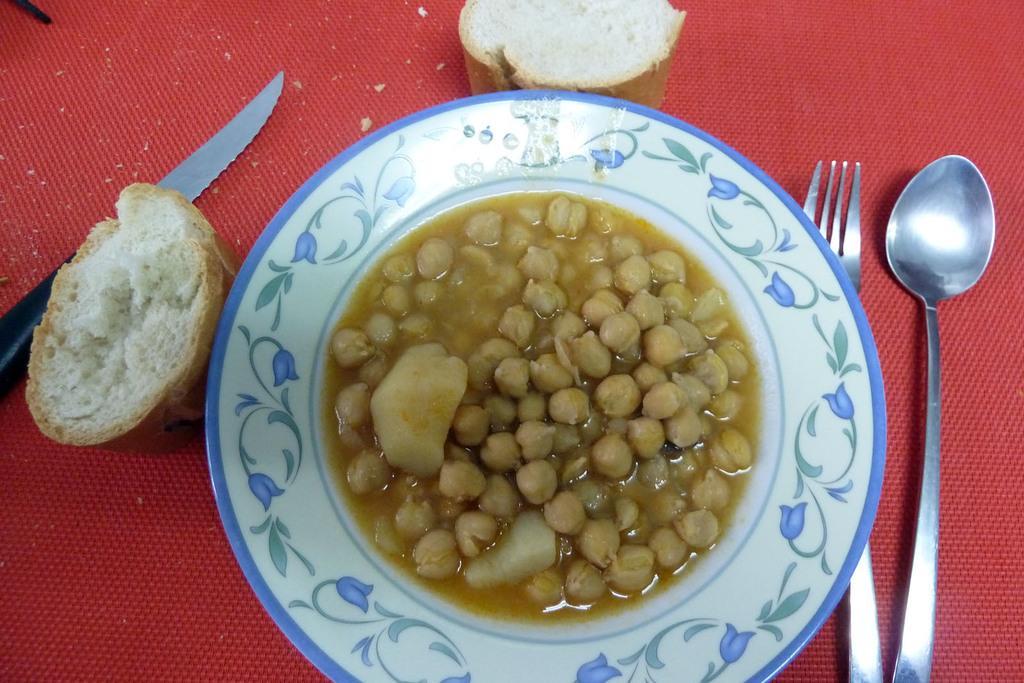Could you give a brief overview of what you see in this image? In this image in the center there is one plate in the plate there are some food, and beside the plate there is one spoon, fork, buns and one knife. 